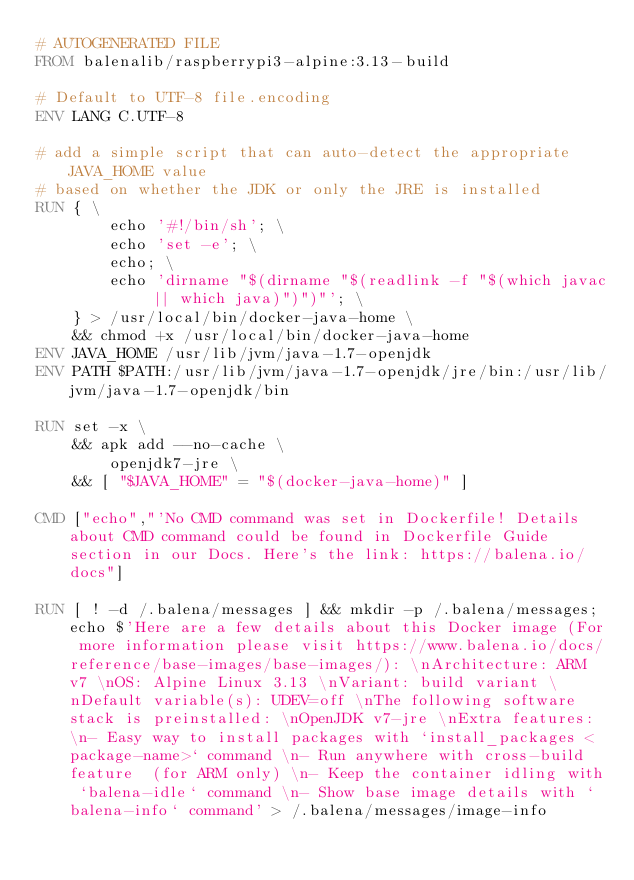<code> <loc_0><loc_0><loc_500><loc_500><_Dockerfile_># AUTOGENERATED FILE
FROM balenalib/raspberrypi3-alpine:3.13-build

# Default to UTF-8 file.encoding
ENV LANG C.UTF-8

# add a simple script that can auto-detect the appropriate JAVA_HOME value
# based on whether the JDK or only the JRE is installed
RUN { \
		echo '#!/bin/sh'; \
		echo 'set -e'; \
		echo; \
		echo 'dirname "$(dirname "$(readlink -f "$(which javac || which java)")")"'; \
	} > /usr/local/bin/docker-java-home \
	&& chmod +x /usr/local/bin/docker-java-home
ENV JAVA_HOME /usr/lib/jvm/java-1.7-openjdk
ENV PATH $PATH:/usr/lib/jvm/java-1.7-openjdk/jre/bin:/usr/lib/jvm/java-1.7-openjdk/bin

RUN set -x \
	&& apk add --no-cache \
		openjdk7-jre \
	&& [ "$JAVA_HOME" = "$(docker-java-home)" ]

CMD ["echo","'No CMD command was set in Dockerfile! Details about CMD command could be found in Dockerfile Guide section in our Docs. Here's the link: https://balena.io/docs"]

RUN [ ! -d /.balena/messages ] && mkdir -p /.balena/messages; echo $'Here are a few details about this Docker image (For more information please visit https://www.balena.io/docs/reference/base-images/base-images/): \nArchitecture: ARM v7 \nOS: Alpine Linux 3.13 \nVariant: build variant \nDefault variable(s): UDEV=off \nThe following software stack is preinstalled: \nOpenJDK v7-jre \nExtra features: \n- Easy way to install packages with `install_packages <package-name>` command \n- Run anywhere with cross-build feature  (for ARM only) \n- Keep the container idling with `balena-idle` command \n- Show base image details with `balena-info` command' > /.balena/messages/image-info</code> 